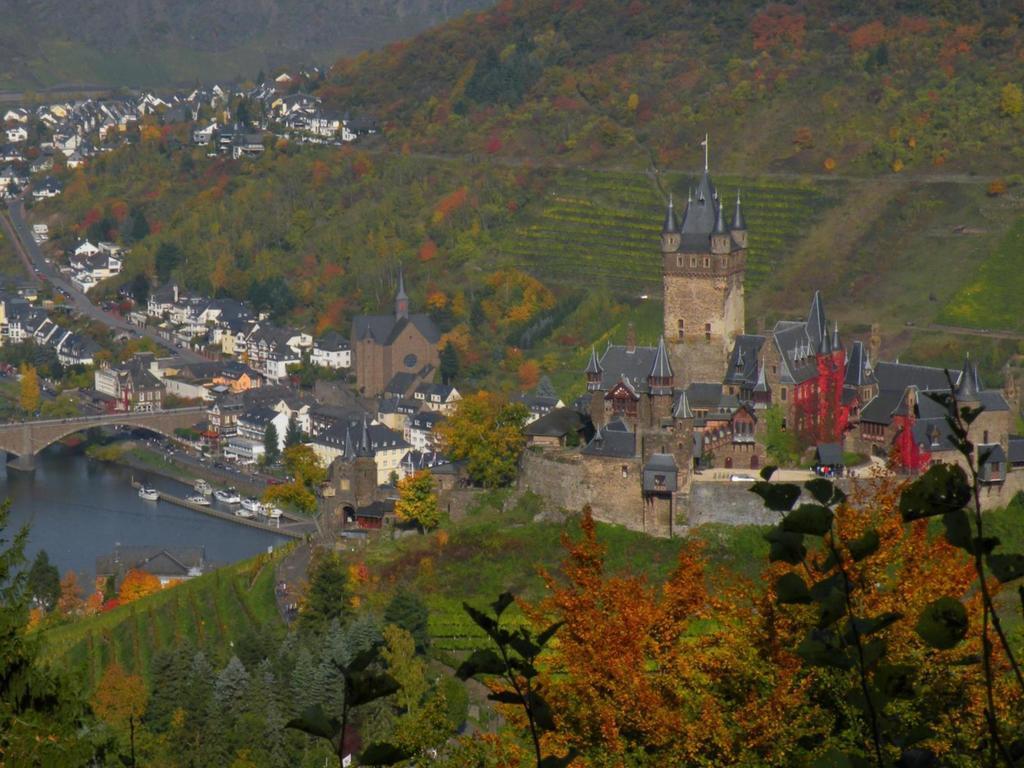In one or two sentences, can you explain what this image depicts? In this image I can see outer view of city and I can see the hill, buildings , tower ,bridge , lake , trees. 